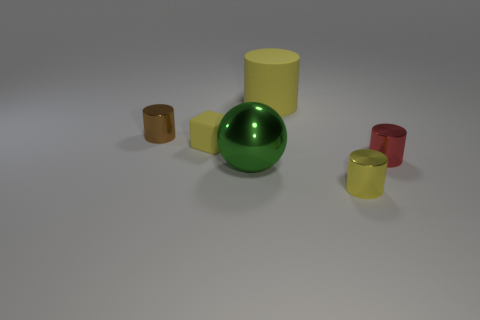Subtract all tiny red shiny cylinders. How many cylinders are left? 3 Add 2 tiny red metal cylinders. How many objects exist? 8 Subtract all red cylinders. How many cylinders are left? 3 Subtract all green balls. How many yellow cylinders are left? 2 Subtract 1 cylinders. How many cylinders are left? 3 Subtract all red cylinders. Subtract all red spheres. How many cylinders are left? 3 Subtract all large yellow cylinders. Subtract all small red metallic cylinders. How many objects are left? 4 Add 3 matte cubes. How many matte cubes are left? 4 Add 4 tiny yellow cylinders. How many tiny yellow cylinders exist? 5 Subtract 0 brown spheres. How many objects are left? 6 